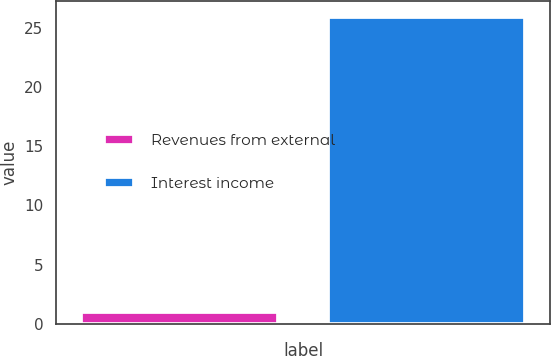<chart> <loc_0><loc_0><loc_500><loc_500><bar_chart><fcel>Revenues from external<fcel>Interest income<nl><fcel>1<fcel>26<nl></chart> 